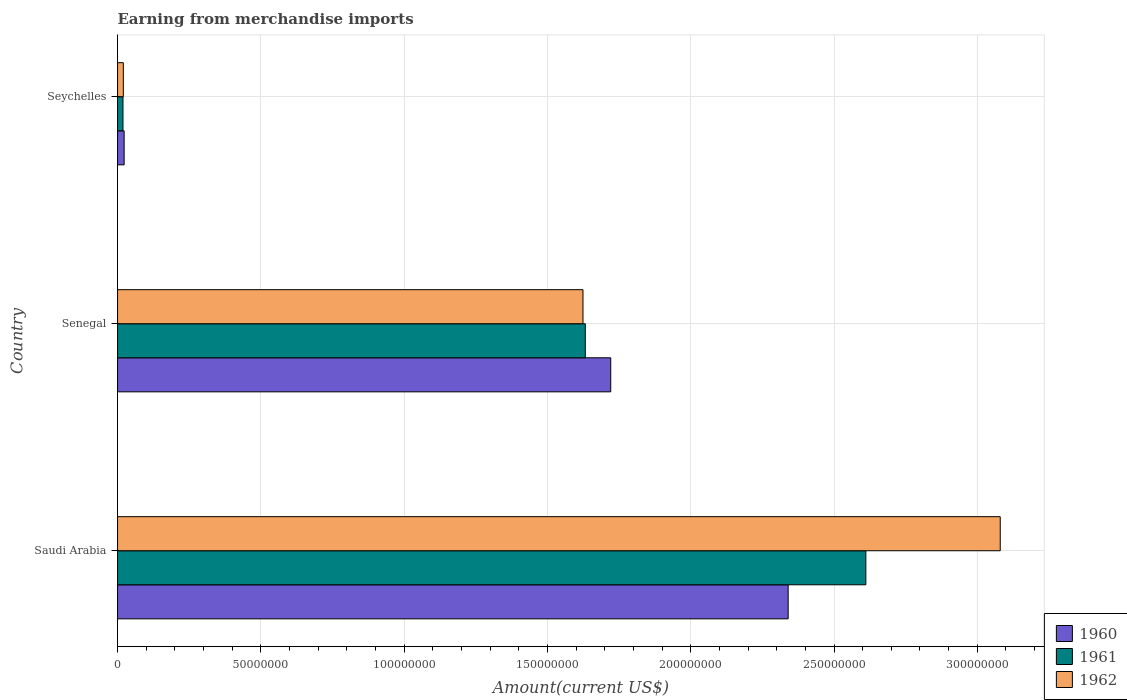Are the number of bars per tick equal to the number of legend labels?
Provide a short and direct response. Yes. Are the number of bars on each tick of the Y-axis equal?
Keep it short and to the point. Yes. How many bars are there on the 3rd tick from the top?
Provide a short and direct response. 3. What is the label of the 3rd group of bars from the top?
Give a very brief answer. Saudi Arabia. In how many cases, is the number of bars for a given country not equal to the number of legend labels?
Offer a terse response. 0. What is the amount earned from merchandise imports in 1962 in Senegal?
Your answer should be compact. 1.62e+08. Across all countries, what is the maximum amount earned from merchandise imports in 1962?
Your answer should be compact. 3.08e+08. Across all countries, what is the minimum amount earned from merchandise imports in 1962?
Provide a succinct answer. 2.01e+06. In which country was the amount earned from merchandise imports in 1960 maximum?
Give a very brief answer. Saudi Arabia. In which country was the amount earned from merchandise imports in 1962 minimum?
Your response must be concise. Seychelles. What is the total amount earned from merchandise imports in 1960 in the graph?
Make the answer very short. 4.08e+08. What is the difference between the amount earned from merchandise imports in 1962 in Senegal and that in Seychelles?
Offer a terse response. 1.60e+08. What is the difference between the amount earned from merchandise imports in 1962 in Saudi Arabia and the amount earned from merchandise imports in 1961 in Seychelles?
Provide a succinct answer. 3.06e+08. What is the average amount earned from merchandise imports in 1962 per country?
Provide a short and direct response. 1.57e+08. What is the difference between the amount earned from merchandise imports in 1962 and amount earned from merchandise imports in 1961 in Saudi Arabia?
Make the answer very short. 4.69e+07. In how many countries, is the amount earned from merchandise imports in 1961 greater than 290000000 US$?
Your answer should be very brief. 0. What is the ratio of the amount earned from merchandise imports in 1961 in Saudi Arabia to that in Senegal?
Your response must be concise. 1.6. Is the amount earned from merchandise imports in 1961 in Saudi Arabia less than that in Seychelles?
Your answer should be very brief. No. What is the difference between the highest and the second highest amount earned from merchandise imports in 1960?
Offer a very short reply. 6.19e+07. What is the difference between the highest and the lowest amount earned from merchandise imports in 1962?
Your answer should be compact. 3.06e+08. In how many countries, is the amount earned from merchandise imports in 1962 greater than the average amount earned from merchandise imports in 1962 taken over all countries?
Offer a very short reply. 2. What does the 2nd bar from the bottom in Saudi Arabia represents?
Give a very brief answer. 1961. How many bars are there?
Your answer should be very brief. 9. Are all the bars in the graph horizontal?
Offer a terse response. Yes. What is the difference between two consecutive major ticks on the X-axis?
Give a very brief answer. 5.00e+07. Does the graph contain grids?
Your response must be concise. Yes. Where does the legend appear in the graph?
Keep it short and to the point. Bottom right. What is the title of the graph?
Your answer should be very brief. Earning from merchandise imports. Does "1965" appear as one of the legend labels in the graph?
Ensure brevity in your answer.  No. What is the label or title of the X-axis?
Your answer should be compact. Amount(current US$). What is the Amount(current US$) of 1960 in Saudi Arabia?
Offer a very short reply. 2.34e+08. What is the Amount(current US$) of 1961 in Saudi Arabia?
Ensure brevity in your answer.  2.61e+08. What is the Amount(current US$) of 1962 in Saudi Arabia?
Offer a terse response. 3.08e+08. What is the Amount(current US$) of 1960 in Senegal?
Your response must be concise. 1.72e+08. What is the Amount(current US$) of 1961 in Senegal?
Make the answer very short. 1.63e+08. What is the Amount(current US$) of 1962 in Senegal?
Your answer should be very brief. 1.62e+08. What is the Amount(current US$) in 1960 in Seychelles?
Your answer should be very brief. 2.30e+06. What is the Amount(current US$) of 1961 in Seychelles?
Your answer should be compact. 1.89e+06. What is the Amount(current US$) of 1962 in Seychelles?
Provide a short and direct response. 2.01e+06. Across all countries, what is the maximum Amount(current US$) in 1960?
Ensure brevity in your answer.  2.34e+08. Across all countries, what is the maximum Amount(current US$) of 1961?
Provide a short and direct response. 2.61e+08. Across all countries, what is the maximum Amount(current US$) in 1962?
Provide a succinct answer. 3.08e+08. Across all countries, what is the minimum Amount(current US$) in 1960?
Ensure brevity in your answer.  2.30e+06. Across all countries, what is the minimum Amount(current US$) of 1961?
Offer a terse response. 1.89e+06. Across all countries, what is the minimum Amount(current US$) in 1962?
Your answer should be compact. 2.01e+06. What is the total Amount(current US$) of 1960 in the graph?
Give a very brief answer. 4.08e+08. What is the total Amount(current US$) in 1961 in the graph?
Offer a terse response. 4.26e+08. What is the total Amount(current US$) of 1962 in the graph?
Your response must be concise. 4.72e+08. What is the difference between the Amount(current US$) of 1960 in Saudi Arabia and that in Senegal?
Offer a very short reply. 6.19e+07. What is the difference between the Amount(current US$) of 1961 in Saudi Arabia and that in Senegal?
Offer a very short reply. 9.79e+07. What is the difference between the Amount(current US$) in 1962 in Saudi Arabia and that in Senegal?
Ensure brevity in your answer.  1.46e+08. What is the difference between the Amount(current US$) of 1960 in Saudi Arabia and that in Seychelles?
Keep it short and to the point. 2.32e+08. What is the difference between the Amount(current US$) in 1961 in Saudi Arabia and that in Seychelles?
Offer a terse response. 2.59e+08. What is the difference between the Amount(current US$) in 1962 in Saudi Arabia and that in Seychelles?
Make the answer very short. 3.06e+08. What is the difference between the Amount(current US$) in 1960 in Senegal and that in Seychelles?
Make the answer very short. 1.70e+08. What is the difference between the Amount(current US$) in 1961 in Senegal and that in Seychelles?
Make the answer very short. 1.61e+08. What is the difference between the Amount(current US$) of 1962 in Senegal and that in Seychelles?
Give a very brief answer. 1.60e+08. What is the difference between the Amount(current US$) in 1960 in Saudi Arabia and the Amount(current US$) in 1961 in Senegal?
Ensure brevity in your answer.  7.08e+07. What is the difference between the Amount(current US$) in 1960 in Saudi Arabia and the Amount(current US$) in 1962 in Senegal?
Keep it short and to the point. 7.16e+07. What is the difference between the Amount(current US$) of 1961 in Saudi Arabia and the Amount(current US$) of 1962 in Senegal?
Make the answer very short. 9.87e+07. What is the difference between the Amount(current US$) of 1960 in Saudi Arabia and the Amount(current US$) of 1961 in Seychelles?
Provide a succinct answer. 2.32e+08. What is the difference between the Amount(current US$) of 1960 in Saudi Arabia and the Amount(current US$) of 1962 in Seychelles?
Provide a short and direct response. 2.32e+08. What is the difference between the Amount(current US$) of 1961 in Saudi Arabia and the Amount(current US$) of 1962 in Seychelles?
Provide a short and direct response. 2.59e+08. What is the difference between the Amount(current US$) of 1960 in Senegal and the Amount(current US$) of 1961 in Seychelles?
Provide a succinct answer. 1.70e+08. What is the difference between the Amount(current US$) of 1960 in Senegal and the Amount(current US$) of 1962 in Seychelles?
Make the answer very short. 1.70e+08. What is the difference between the Amount(current US$) in 1961 in Senegal and the Amount(current US$) in 1962 in Seychelles?
Offer a terse response. 1.61e+08. What is the average Amount(current US$) in 1960 per country?
Provide a succinct answer. 1.36e+08. What is the average Amount(current US$) of 1961 per country?
Your answer should be compact. 1.42e+08. What is the average Amount(current US$) in 1962 per country?
Your answer should be compact. 1.57e+08. What is the difference between the Amount(current US$) in 1960 and Amount(current US$) in 1961 in Saudi Arabia?
Make the answer very short. -2.71e+07. What is the difference between the Amount(current US$) in 1960 and Amount(current US$) in 1962 in Saudi Arabia?
Ensure brevity in your answer.  -7.40e+07. What is the difference between the Amount(current US$) in 1961 and Amount(current US$) in 1962 in Saudi Arabia?
Provide a succinct answer. -4.69e+07. What is the difference between the Amount(current US$) in 1960 and Amount(current US$) in 1961 in Senegal?
Ensure brevity in your answer.  8.87e+06. What is the difference between the Amount(current US$) in 1960 and Amount(current US$) in 1962 in Senegal?
Keep it short and to the point. 9.68e+06. What is the difference between the Amount(current US$) in 1961 and Amount(current US$) in 1962 in Senegal?
Your response must be concise. 8.11e+05. What is the difference between the Amount(current US$) of 1960 and Amount(current US$) of 1961 in Seychelles?
Give a very brief answer. 4.08e+05. What is the difference between the Amount(current US$) in 1960 and Amount(current US$) in 1962 in Seychelles?
Ensure brevity in your answer.  2.86e+05. What is the difference between the Amount(current US$) of 1961 and Amount(current US$) of 1962 in Seychelles?
Keep it short and to the point. -1.22e+05. What is the ratio of the Amount(current US$) of 1960 in Saudi Arabia to that in Senegal?
Make the answer very short. 1.36. What is the ratio of the Amount(current US$) of 1961 in Saudi Arabia to that in Senegal?
Offer a very short reply. 1.6. What is the ratio of the Amount(current US$) of 1962 in Saudi Arabia to that in Senegal?
Keep it short and to the point. 1.9. What is the ratio of the Amount(current US$) in 1960 in Saudi Arabia to that in Seychelles?
Your response must be concise. 101.74. What is the ratio of the Amount(current US$) in 1961 in Saudi Arabia to that in Seychelles?
Your answer should be compact. 138. What is the ratio of the Amount(current US$) of 1962 in Saudi Arabia to that in Seychelles?
Ensure brevity in your answer.  152.94. What is the ratio of the Amount(current US$) in 1960 in Senegal to that in Seychelles?
Ensure brevity in your answer.  74.82. What is the ratio of the Amount(current US$) in 1961 in Senegal to that in Seychelles?
Your answer should be very brief. 86.26. What is the ratio of the Amount(current US$) of 1962 in Senegal to that in Seychelles?
Your response must be concise. 80.64. What is the difference between the highest and the second highest Amount(current US$) in 1960?
Your answer should be compact. 6.19e+07. What is the difference between the highest and the second highest Amount(current US$) in 1961?
Offer a very short reply. 9.79e+07. What is the difference between the highest and the second highest Amount(current US$) of 1962?
Your answer should be very brief. 1.46e+08. What is the difference between the highest and the lowest Amount(current US$) of 1960?
Make the answer very short. 2.32e+08. What is the difference between the highest and the lowest Amount(current US$) of 1961?
Make the answer very short. 2.59e+08. What is the difference between the highest and the lowest Amount(current US$) of 1962?
Make the answer very short. 3.06e+08. 